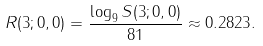Convert formula to latex. <formula><loc_0><loc_0><loc_500><loc_500>R ( 3 ; 0 , 0 ) = \frac { \log _ { 9 } S ( 3 ; 0 , 0 ) } { 8 1 } \approx 0 . 2 8 2 3 .</formula> 